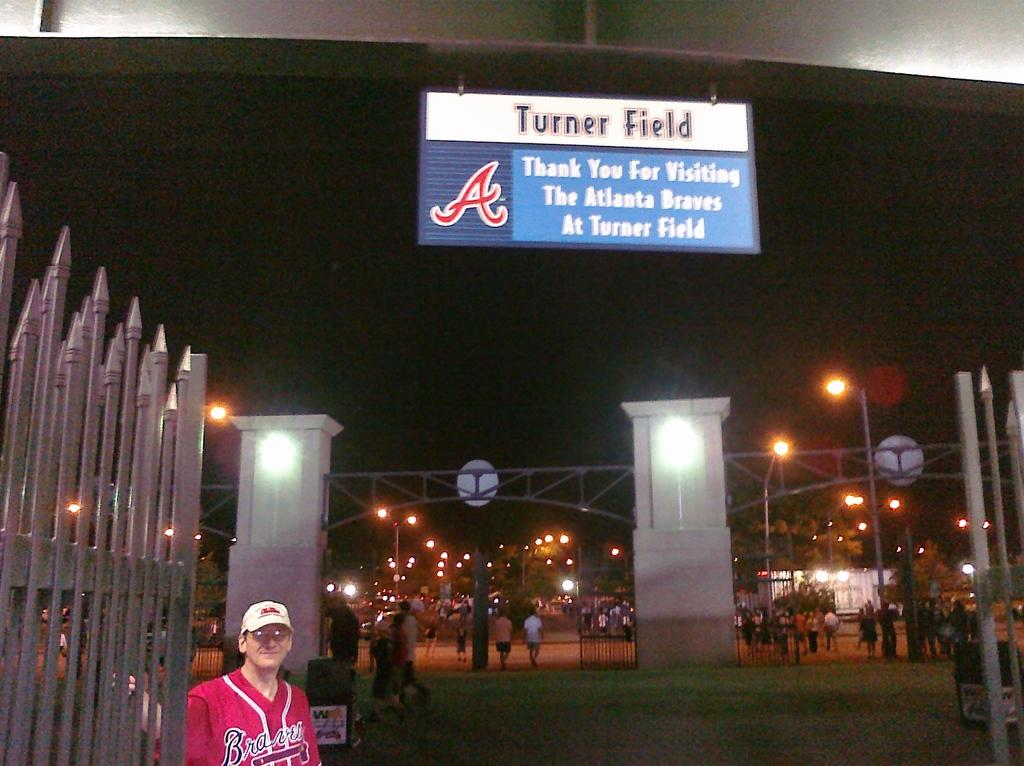<image>
Provide a brief description of the given image. A man wearing a red Atlanta Braves jersey standing in front of a sign that says "Turner Field." 